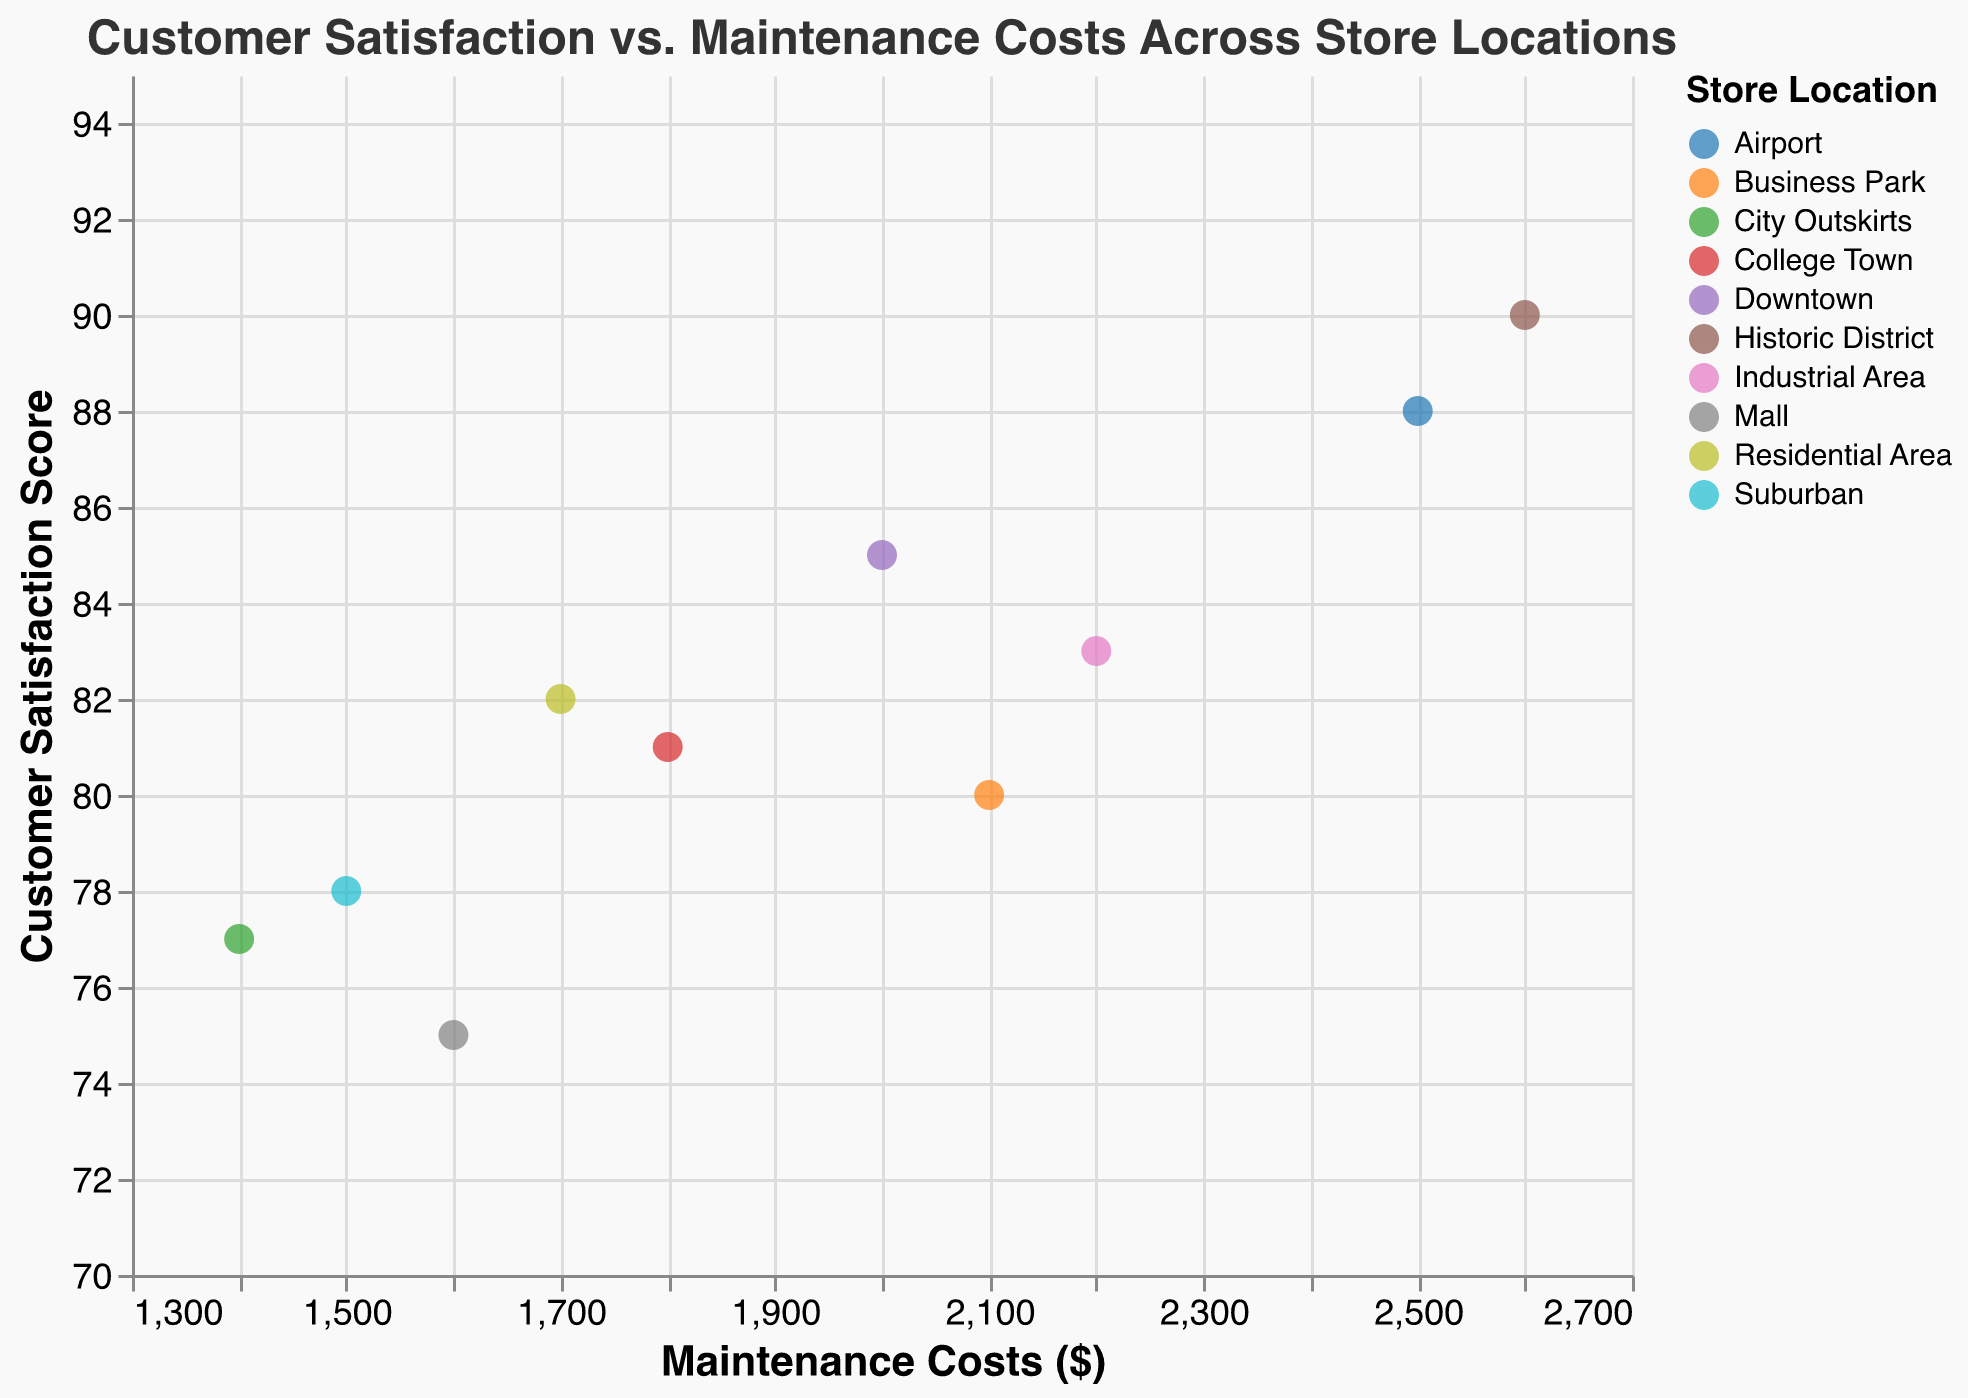How many store locations are represented in the plot? Count the number of distinct store locations in the legend, each represented by a unique color.
Answer: 10 What's the store with the highest customer satisfaction score, and what is that score? Locate the point with the highest vertical position on the y-axis labeled "Customer Satisfaction Score." Hover over or check the tooltip to find the respective store location and score.
Answer: Historic District, 90 Which store has the lowest maintenance costs, and what are those costs? Locate the point with the lowest horizontal position on the x-axis labeled "Maintenance Costs ($)." Hover over or check the tooltip to find the respective store location and costs.
Answer: City Outskirts, $1400 How does the customer satisfaction score relate to maintenance costs in the Downtown location? Look for the point corresponding to "Downtown" in the legend. Check its coordinates: the y-axis for satisfaction score and the x-axis for maintenance costs (85, $2000).
Answer: Satisfaction Score: 85, Maintenance Costs: $2000 What's the difference in maintenance costs between the Airport and Downtown locations? Identify the points for "Airport" and "Downtown." Subtract the maintenance costs of Downtown from Airport ($2500 - $2000 = $500).
Answer: $500 Which store location has a customer satisfaction score of 78? Locate the point that aligns horizontally with the y-axis value of 78. Hover over or check the tooltip to find the corresponding store.
Answer: Suburban What is the average customer satisfaction score of the stores with maintenance costs above $2000? Identify points with maintenance costs greater than $2000 (Airport, Industrial Area, Historic District, Business Park). Calculate the average of their customer satisfaction scores: (88 + 83 + 90 + 80)/4 = 85.25.
Answer: 85.25 Are there any store locations with the same customer satisfaction score? If yes, name them and the score. Look for points that align perfectly horizontally on the y-axis. Check the tooltip to confirm the store locations and scores.
Answer: No, all customer satisfaction scores are unique 